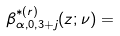Convert formula to latex. <formula><loc_0><loc_0><loc_500><loc_500>\beta ^ { \ast ( r ) } _ { \alpha , 0 , 3 + j } ( z ; \nu ) =</formula> 